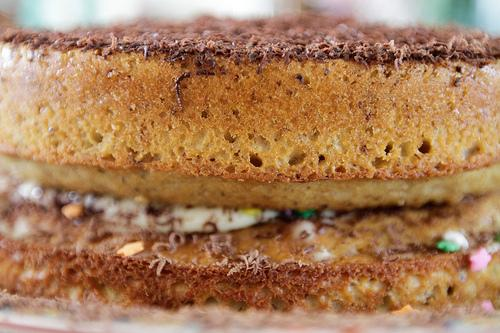How many layers does the cake have and what are their characteristics? The cake has two layers - a light brown layer and a dark brown top layer, with cream filling in between. What type of dessert is shown in the image and what are some of its distinct features? The dessert is a layered cake with brown and golden brown edges, cream filling, and star-shaped colorful sprinkles as decorations. Describe the texture of the exterior of the cake. The cake has a toasty, crusty, and frizzle brown exterior with a light and dark brown top and spongy holes throughout. Identify the main colors and objects of the decorations in the cake. The main decorations are star-shaped sprinkles in orange, green, pink, and white colors. Mention the main subject and its sentiment in the image. The main subject is a beautifully decorated layered cake, evoking a sense of celebration and indulgence. Explain the composition of the cream filling in the cake. The cream filling is white, has yellow bits, small orange confetti, and is sandwiched between the upper and lower cake layers. List three objects in the image and their sizes. Brown edge of a cake, dark brown grated chocolate, and cream filling of cake. List all the decorations on the cake in the image and their sizes. Green star sprinkle, pink star sprinkle, white star sprinkle, orange star sprinkle, and grated chocolate. 